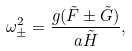Convert formula to latex. <formula><loc_0><loc_0><loc_500><loc_500>\omega _ { \pm } ^ { 2 } = \frac { g ( \tilde { F } \pm \tilde { G } ) } { a \tilde { H } } ,</formula> 